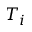<formula> <loc_0><loc_0><loc_500><loc_500>T _ { i }</formula> 